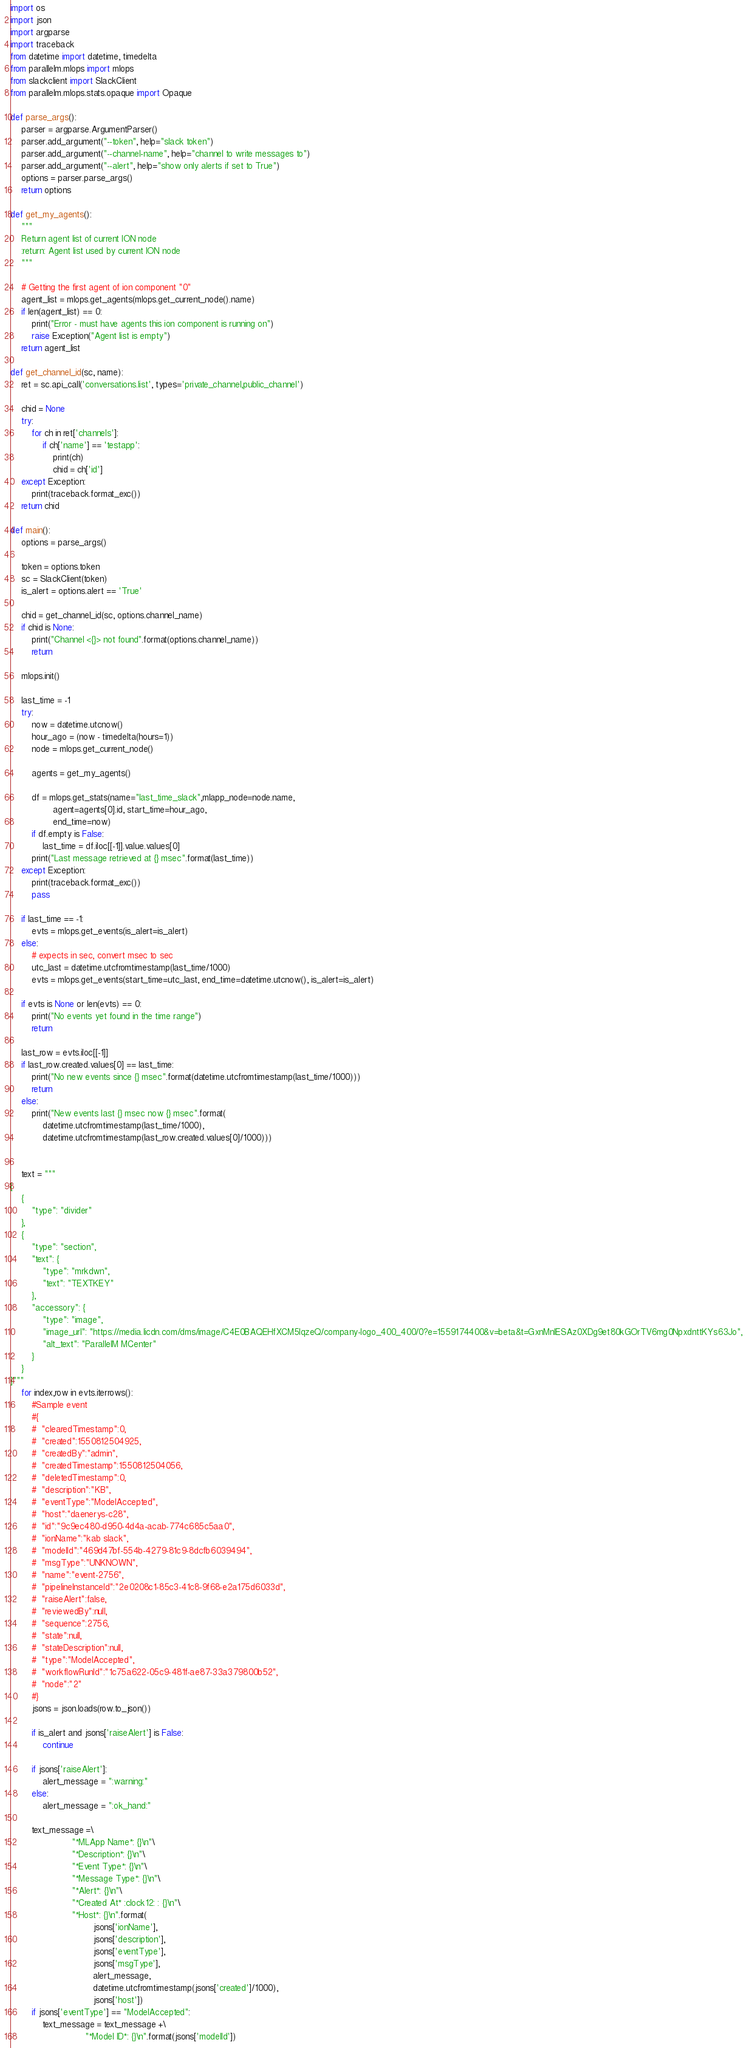Convert code to text. <code><loc_0><loc_0><loc_500><loc_500><_Python_>import os
import json
import argparse
import traceback
from datetime import datetime, timedelta
from parallelm.mlops import mlops
from slackclient import SlackClient
from parallelm.mlops.stats.opaque import Opaque

def parse_args():
    parser = argparse.ArgumentParser()
    parser.add_argument("--token", help="slack token")
    parser.add_argument("--channel-name", help="channel to write messages to")
    parser.add_argument("--alert", help="show only alerts if set to True")
    options = parser.parse_args()
    return options

def get_my_agents():
    """
    Return agent list of current ION node
    :return: Agent list used by current ION node
    """

    # Getting the first agent of ion component "0"
    agent_list = mlops.get_agents(mlops.get_current_node().name)
    if len(agent_list) == 0:
        print("Error - must have agents this ion component is running on")
        raise Exception("Agent list is empty")
    return agent_list

def get_channel_id(sc, name):
    ret = sc.api_call('conversations.list', types='private_channel,public_channel')

    chid = None
    try:
        for ch in ret['channels']:
            if ch['name'] == 'testapp':
                print(ch)
                chid = ch['id']
    except Exception:
        print(traceback.format_exc())
    return chid

def main():
    options = parse_args()

    token = options.token
    sc = SlackClient(token)
    is_alert = options.alert == 'True'

    chid = get_channel_id(sc, options.channel_name)
    if chid is None:
        print("Channel <{}> not found".format(options.channel_name))
        return

    mlops.init()

    last_time = -1
    try:
        now = datetime.utcnow()
        hour_ago = (now - timedelta(hours=1))
        node = mlops.get_current_node()

        agents = get_my_agents()

        df = mlops.get_stats(name="last_time_slack",mlapp_node=node.name,
                agent=agents[0].id, start_time=hour_ago,
                end_time=now)
        if df.empty is False:
            last_time = df.iloc[[-1]].value.values[0]
        print("Last message retrieved at {} msec".format(last_time))
    except Exception:
        print(traceback.format_exc())
        pass
    
    if last_time == -1:
        evts = mlops.get_events(is_alert=is_alert)
    else:
        # expects in sec, convert msec to sec
        utc_last = datetime.utcfromtimestamp(last_time/1000)
        evts = mlops.get_events(start_time=utc_last, end_time=datetime.utcnow(), is_alert=is_alert)

    if evts is None or len(evts) == 0:
        print("No events yet found in the time range")
        return

    last_row = evts.iloc[[-1]]
    if last_row.created.values[0] == last_time:
        print("No new events since {} msec".format(datetime.utcfromtimestamp(last_time/1000)))
        return
    else:
        print("New events last {} msec now {} msec".format(
            datetime.utcfromtimestamp(last_time/1000),
            datetime.utcfromtimestamp(last_row.created.values[0]/1000)))


    text = """
[
    {
        "type": "divider"
    },
    {
        "type": "section",
        "text": {
            "type": "mrkdwn",
            "text": "TEXTKEY"
        },
        "accessory": {
            "type": "image",
            "image_url": "https://media.licdn.com/dms/image/C4E0BAQEHfXCM5IqzeQ/company-logo_400_400/0?e=1559174400&v=beta&t=GxnMnlESAz0XDg9et80kGOrTV6mg0NpxdnttKYs63Jo",
            "alt_text": "ParallelM MCenter"
        }
    }
]"""
    for index,row in evts.iterrows():
        #Sample event
        #{
        #  "clearedTimestamp":0,
        #  "created":1550812504925,
        #  "createdBy":"admin",
        #  "createdTimestamp":1550812504056,
        #  "deletedTimestamp":0,
        #  "description":"KB",
        #  "eventType":"ModelAccepted",
        #  "host":"daenerys-c28",
        #  "id":"9c9ec480-d950-4d4a-acab-774c685c5aa0",
        #  "ionName":"kab slack",
        #  "modelId":"469d47bf-554b-4279-81c9-8dcfb6039494",
        #  "msgType":"UNKNOWN",
        #  "name":"event-2756",
        #  "pipelineInstanceId":"2e0208c1-85c3-41c8-9f68-e2a175d6033d",
        #  "raiseAlert":false,
        #  "reviewedBy":null,
        #  "sequence":2756,
        #  "state":null,
        #  "stateDescription":null,
        #  "type":"ModelAccepted",
        #  "workflowRunId":"1c75a622-05c9-481f-ae87-33a379800b52",
        #  "node":"2"
        #}
        jsons = json.loads(row.to_json())

        if is_alert and jsons['raiseAlert'] is False:
            continue

        if jsons['raiseAlert']:
            alert_message = ":warning:"
        else:
            alert_message = ":ok_hand:"

        text_message =\
                       "*MLApp Name*: {}\n"\
                       "*Description*: {}\n"\
                       "*Event Type*: {}\n"\
                       "*Message Type*: {}\n"\
                       "*Alert*: {}\n"\
                       "*Created At* :clock12: : {}\n"\
                       "*Host*: {}\n".format(
                               jsons['ionName'],
                               jsons['description'],
                               jsons['eventType'],
                               jsons['msgType'],
                               alert_message,
                               datetime.utcfromtimestamp(jsons['created']/1000),
                               jsons['host'])
        if jsons['eventType'] == "ModelAccepted":
            text_message = text_message +\
                            "*Model ID*: {}\n".format(jsons['modelId'])
</code> 